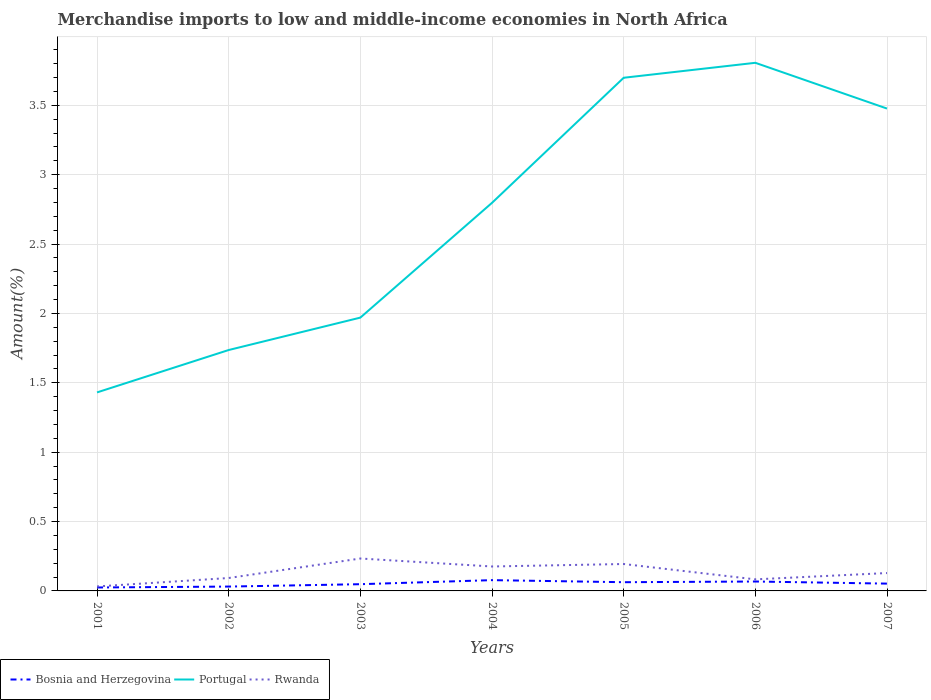How many different coloured lines are there?
Offer a terse response. 3. Is the number of lines equal to the number of legend labels?
Offer a terse response. Yes. Across all years, what is the maximum percentage of amount earned from merchandise imports in Rwanda?
Provide a succinct answer. 0.03. In which year was the percentage of amount earned from merchandise imports in Portugal maximum?
Keep it short and to the point. 2001. What is the total percentage of amount earned from merchandise imports in Portugal in the graph?
Your response must be concise. -1.51. What is the difference between the highest and the second highest percentage of amount earned from merchandise imports in Rwanda?
Make the answer very short. 0.2. What is the difference between the highest and the lowest percentage of amount earned from merchandise imports in Rwanda?
Your answer should be very brief. 3. What is the difference between two consecutive major ticks on the Y-axis?
Your response must be concise. 0.5. Does the graph contain any zero values?
Give a very brief answer. No. Does the graph contain grids?
Give a very brief answer. Yes. Where does the legend appear in the graph?
Provide a short and direct response. Bottom left. How are the legend labels stacked?
Provide a short and direct response. Horizontal. What is the title of the graph?
Make the answer very short. Merchandise imports to low and middle-income economies in North Africa. What is the label or title of the X-axis?
Your answer should be very brief. Years. What is the label or title of the Y-axis?
Provide a short and direct response. Amount(%). What is the Amount(%) in Bosnia and Herzegovina in 2001?
Your answer should be very brief. 0.02. What is the Amount(%) of Portugal in 2001?
Offer a terse response. 1.43. What is the Amount(%) of Rwanda in 2001?
Offer a terse response. 0.03. What is the Amount(%) of Bosnia and Herzegovina in 2002?
Ensure brevity in your answer.  0.03. What is the Amount(%) in Portugal in 2002?
Your response must be concise. 1.74. What is the Amount(%) in Rwanda in 2002?
Offer a very short reply. 0.09. What is the Amount(%) in Bosnia and Herzegovina in 2003?
Keep it short and to the point. 0.05. What is the Amount(%) of Portugal in 2003?
Your answer should be very brief. 1.97. What is the Amount(%) in Rwanda in 2003?
Provide a short and direct response. 0.23. What is the Amount(%) in Bosnia and Herzegovina in 2004?
Keep it short and to the point. 0.08. What is the Amount(%) in Portugal in 2004?
Keep it short and to the point. 2.8. What is the Amount(%) in Rwanda in 2004?
Make the answer very short. 0.18. What is the Amount(%) in Bosnia and Herzegovina in 2005?
Make the answer very short. 0.06. What is the Amount(%) of Portugal in 2005?
Provide a succinct answer. 3.7. What is the Amount(%) of Rwanda in 2005?
Keep it short and to the point. 0.19. What is the Amount(%) of Bosnia and Herzegovina in 2006?
Offer a very short reply. 0.07. What is the Amount(%) in Portugal in 2006?
Give a very brief answer. 3.81. What is the Amount(%) of Rwanda in 2006?
Offer a terse response. 0.08. What is the Amount(%) in Bosnia and Herzegovina in 2007?
Your answer should be very brief. 0.05. What is the Amount(%) in Portugal in 2007?
Provide a succinct answer. 3.48. What is the Amount(%) of Rwanda in 2007?
Ensure brevity in your answer.  0.13. Across all years, what is the maximum Amount(%) of Bosnia and Herzegovina?
Offer a terse response. 0.08. Across all years, what is the maximum Amount(%) in Portugal?
Keep it short and to the point. 3.81. Across all years, what is the maximum Amount(%) in Rwanda?
Provide a succinct answer. 0.23. Across all years, what is the minimum Amount(%) in Bosnia and Herzegovina?
Your response must be concise. 0.02. Across all years, what is the minimum Amount(%) of Portugal?
Make the answer very short. 1.43. Across all years, what is the minimum Amount(%) of Rwanda?
Provide a short and direct response. 0.03. What is the total Amount(%) of Bosnia and Herzegovina in the graph?
Your answer should be compact. 0.37. What is the total Amount(%) of Portugal in the graph?
Make the answer very short. 18.92. What is the total Amount(%) in Rwanda in the graph?
Your answer should be compact. 0.94. What is the difference between the Amount(%) of Bosnia and Herzegovina in 2001 and that in 2002?
Provide a succinct answer. -0.01. What is the difference between the Amount(%) of Portugal in 2001 and that in 2002?
Ensure brevity in your answer.  -0.31. What is the difference between the Amount(%) in Rwanda in 2001 and that in 2002?
Provide a short and direct response. -0.06. What is the difference between the Amount(%) in Bosnia and Herzegovina in 2001 and that in 2003?
Ensure brevity in your answer.  -0.02. What is the difference between the Amount(%) of Portugal in 2001 and that in 2003?
Make the answer very short. -0.54. What is the difference between the Amount(%) in Rwanda in 2001 and that in 2003?
Make the answer very short. -0.2. What is the difference between the Amount(%) of Bosnia and Herzegovina in 2001 and that in 2004?
Provide a short and direct response. -0.05. What is the difference between the Amount(%) of Portugal in 2001 and that in 2004?
Make the answer very short. -1.37. What is the difference between the Amount(%) in Rwanda in 2001 and that in 2004?
Ensure brevity in your answer.  -0.14. What is the difference between the Amount(%) of Bosnia and Herzegovina in 2001 and that in 2005?
Provide a succinct answer. -0.04. What is the difference between the Amount(%) of Portugal in 2001 and that in 2005?
Offer a terse response. -2.27. What is the difference between the Amount(%) in Rwanda in 2001 and that in 2005?
Make the answer very short. -0.16. What is the difference between the Amount(%) of Bosnia and Herzegovina in 2001 and that in 2006?
Make the answer very short. -0.04. What is the difference between the Amount(%) of Portugal in 2001 and that in 2006?
Provide a succinct answer. -2.38. What is the difference between the Amount(%) in Rwanda in 2001 and that in 2006?
Your answer should be very brief. -0.05. What is the difference between the Amount(%) in Bosnia and Herzegovina in 2001 and that in 2007?
Ensure brevity in your answer.  -0.03. What is the difference between the Amount(%) in Portugal in 2001 and that in 2007?
Your answer should be very brief. -2.05. What is the difference between the Amount(%) of Rwanda in 2001 and that in 2007?
Provide a short and direct response. -0.1. What is the difference between the Amount(%) of Bosnia and Herzegovina in 2002 and that in 2003?
Ensure brevity in your answer.  -0.02. What is the difference between the Amount(%) of Portugal in 2002 and that in 2003?
Provide a short and direct response. -0.23. What is the difference between the Amount(%) of Rwanda in 2002 and that in 2003?
Provide a short and direct response. -0.14. What is the difference between the Amount(%) in Bosnia and Herzegovina in 2002 and that in 2004?
Provide a short and direct response. -0.05. What is the difference between the Amount(%) of Portugal in 2002 and that in 2004?
Make the answer very short. -1.06. What is the difference between the Amount(%) in Rwanda in 2002 and that in 2004?
Your answer should be very brief. -0.08. What is the difference between the Amount(%) in Bosnia and Herzegovina in 2002 and that in 2005?
Offer a very short reply. -0.03. What is the difference between the Amount(%) in Portugal in 2002 and that in 2005?
Ensure brevity in your answer.  -1.96. What is the difference between the Amount(%) of Rwanda in 2002 and that in 2005?
Make the answer very short. -0.1. What is the difference between the Amount(%) in Bosnia and Herzegovina in 2002 and that in 2006?
Your answer should be compact. -0.04. What is the difference between the Amount(%) of Portugal in 2002 and that in 2006?
Keep it short and to the point. -2.07. What is the difference between the Amount(%) of Rwanda in 2002 and that in 2006?
Provide a succinct answer. 0.01. What is the difference between the Amount(%) of Bosnia and Herzegovina in 2002 and that in 2007?
Your answer should be very brief. -0.02. What is the difference between the Amount(%) in Portugal in 2002 and that in 2007?
Provide a short and direct response. -1.74. What is the difference between the Amount(%) in Rwanda in 2002 and that in 2007?
Ensure brevity in your answer.  -0.04. What is the difference between the Amount(%) in Bosnia and Herzegovina in 2003 and that in 2004?
Your answer should be compact. -0.03. What is the difference between the Amount(%) in Portugal in 2003 and that in 2004?
Provide a succinct answer. -0.83. What is the difference between the Amount(%) in Rwanda in 2003 and that in 2004?
Offer a very short reply. 0.06. What is the difference between the Amount(%) in Bosnia and Herzegovina in 2003 and that in 2005?
Your answer should be compact. -0.01. What is the difference between the Amount(%) in Portugal in 2003 and that in 2005?
Provide a succinct answer. -1.73. What is the difference between the Amount(%) of Rwanda in 2003 and that in 2005?
Offer a terse response. 0.04. What is the difference between the Amount(%) in Bosnia and Herzegovina in 2003 and that in 2006?
Your answer should be very brief. -0.02. What is the difference between the Amount(%) of Portugal in 2003 and that in 2006?
Your answer should be very brief. -1.84. What is the difference between the Amount(%) of Rwanda in 2003 and that in 2006?
Provide a succinct answer. 0.15. What is the difference between the Amount(%) of Bosnia and Herzegovina in 2003 and that in 2007?
Give a very brief answer. -0. What is the difference between the Amount(%) in Portugal in 2003 and that in 2007?
Your answer should be compact. -1.51. What is the difference between the Amount(%) of Rwanda in 2003 and that in 2007?
Give a very brief answer. 0.1. What is the difference between the Amount(%) of Bosnia and Herzegovina in 2004 and that in 2005?
Give a very brief answer. 0.01. What is the difference between the Amount(%) of Portugal in 2004 and that in 2005?
Offer a terse response. -0.9. What is the difference between the Amount(%) in Rwanda in 2004 and that in 2005?
Make the answer very short. -0.02. What is the difference between the Amount(%) of Bosnia and Herzegovina in 2004 and that in 2006?
Provide a succinct answer. 0.01. What is the difference between the Amount(%) in Portugal in 2004 and that in 2006?
Ensure brevity in your answer.  -1.01. What is the difference between the Amount(%) in Rwanda in 2004 and that in 2006?
Keep it short and to the point. 0.09. What is the difference between the Amount(%) of Bosnia and Herzegovina in 2004 and that in 2007?
Your answer should be very brief. 0.03. What is the difference between the Amount(%) of Portugal in 2004 and that in 2007?
Provide a short and direct response. -0.68. What is the difference between the Amount(%) in Rwanda in 2004 and that in 2007?
Offer a very short reply. 0.05. What is the difference between the Amount(%) in Bosnia and Herzegovina in 2005 and that in 2006?
Offer a very short reply. -0.01. What is the difference between the Amount(%) in Portugal in 2005 and that in 2006?
Provide a short and direct response. -0.11. What is the difference between the Amount(%) in Rwanda in 2005 and that in 2006?
Give a very brief answer. 0.11. What is the difference between the Amount(%) in Bosnia and Herzegovina in 2005 and that in 2007?
Make the answer very short. 0.01. What is the difference between the Amount(%) of Portugal in 2005 and that in 2007?
Keep it short and to the point. 0.22. What is the difference between the Amount(%) in Rwanda in 2005 and that in 2007?
Your response must be concise. 0.07. What is the difference between the Amount(%) of Bosnia and Herzegovina in 2006 and that in 2007?
Provide a succinct answer. 0.02. What is the difference between the Amount(%) in Portugal in 2006 and that in 2007?
Make the answer very short. 0.33. What is the difference between the Amount(%) of Rwanda in 2006 and that in 2007?
Offer a very short reply. -0.05. What is the difference between the Amount(%) of Bosnia and Herzegovina in 2001 and the Amount(%) of Portugal in 2002?
Keep it short and to the point. -1.71. What is the difference between the Amount(%) of Bosnia and Herzegovina in 2001 and the Amount(%) of Rwanda in 2002?
Offer a very short reply. -0.07. What is the difference between the Amount(%) of Portugal in 2001 and the Amount(%) of Rwanda in 2002?
Your response must be concise. 1.34. What is the difference between the Amount(%) in Bosnia and Herzegovina in 2001 and the Amount(%) in Portugal in 2003?
Your answer should be compact. -1.95. What is the difference between the Amount(%) of Bosnia and Herzegovina in 2001 and the Amount(%) of Rwanda in 2003?
Offer a very short reply. -0.21. What is the difference between the Amount(%) of Portugal in 2001 and the Amount(%) of Rwanda in 2003?
Keep it short and to the point. 1.2. What is the difference between the Amount(%) of Bosnia and Herzegovina in 2001 and the Amount(%) of Portugal in 2004?
Keep it short and to the point. -2.77. What is the difference between the Amount(%) of Bosnia and Herzegovina in 2001 and the Amount(%) of Rwanda in 2004?
Offer a terse response. -0.15. What is the difference between the Amount(%) of Portugal in 2001 and the Amount(%) of Rwanda in 2004?
Offer a very short reply. 1.25. What is the difference between the Amount(%) in Bosnia and Herzegovina in 2001 and the Amount(%) in Portugal in 2005?
Give a very brief answer. -3.67. What is the difference between the Amount(%) of Bosnia and Herzegovina in 2001 and the Amount(%) of Rwanda in 2005?
Ensure brevity in your answer.  -0.17. What is the difference between the Amount(%) in Portugal in 2001 and the Amount(%) in Rwanda in 2005?
Offer a very short reply. 1.24. What is the difference between the Amount(%) in Bosnia and Herzegovina in 2001 and the Amount(%) in Portugal in 2006?
Make the answer very short. -3.78. What is the difference between the Amount(%) in Bosnia and Herzegovina in 2001 and the Amount(%) in Rwanda in 2006?
Give a very brief answer. -0.06. What is the difference between the Amount(%) of Portugal in 2001 and the Amount(%) of Rwanda in 2006?
Provide a short and direct response. 1.35. What is the difference between the Amount(%) of Bosnia and Herzegovina in 2001 and the Amount(%) of Portugal in 2007?
Provide a short and direct response. -3.45. What is the difference between the Amount(%) of Bosnia and Herzegovina in 2001 and the Amount(%) of Rwanda in 2007?
Ensure brevity in your answer.  -0.1. What is the difference between the Amount(%) of Portugal in 2001 and the Amount(%) of Rwanda in 2007?
Your answer should be very brief. 1.3. What is the difference between the Amount(%) in Bosnia and Herzegovina in 2002 and the Amount(%) in Portugal in 2003?
Your answer should be compact. -1.94. What is the difference between the Amount(%) in Bosnia and Herzegovina in 2002 and the Amount(%) in Rwanda in 2003?
Keep it short and to the point. -0.2. What is the difference between the Amount(%) of Portugal in 2002 and the Amount(%) of Rwanda in 2003?
Ensure brevity in your answer.  1.5. What is the difference between the Amount(%) in Bosnia and Herzegovina in 2002 and the Amount(%) in Portugal in 2004?
Your answer should be very brief. -2.77. What is the difference between the Amount(%) of Bosnia and Herzegovina in 2002 and the Amount(%) of Rwanda in 2004?
Make the answer very short. -0.14. What is the difference between the Amount(%) in Portugal in 2002 and the Amount(%) in Rwanda in 2004?
Provide a succinct answer. 1.56. What is the difference between the Amount(%) of Bosnia and Herzegovina in 2002 and the Amount(%) of Portugal in 2005?
Your answer should be compact. -3.67. What is the difference between the Amount(%) in Bosnia and Herzegovina in 2002 and the Amount(%) in Rwanda in 2005?
Offer a very short reply. -0.16. What is the difference between the Amount(%) in Portugal in 2002 and the Amount(%) in Rwanda in 2005?
Provide a succinct answer. 1.54. What is the difference between the Amount(%) in Bosnia and Herzegovina in 2002 and the Amount(%) in Portugal in 2006?
Give a very brief answer. -3.77. What is the difference between the Amount(%) in Bosnia and Herzegovina in 2002 and the Amount(%) in Rwanda in 2006?
Make the answer very short. -0.05. What is the difference between the Amount(%) in Portugal in 2002 and the Amount(%) in Rwanda in 2006?
Ensure brevity in your answer.  1.65. What is the difference between the Amount(%) in Bosnia and Herzegovina in 2002 and the Amount(%) in Portugal in 2007?
Your response must be concise. -3.45. What is the difference between the Amount(%) in Bosnia and Herzegovina in 2002 and the Amount(%) in Rwanda in 2007?
Provide a short and direct response. -0.1. What is the difference between the Amount(%) of Portugal in 2002 and the Amount(%) of Rwanda in 2007?
Your response must be concise. 1.61. What is the difference between the Amount(%) of Bosnia and Herzegovina in 2003 and the Amount(%) of Portugal in 2004?
Provide a short and direct response. -2.75. What is the difference between the Amount(%) in Bosnia and Herzegovina in 2003 and the Amount(%) in Rwanda in 2004?
Your response must be concise. -0.13. What is the difference between the Amount(%) in Portugal in 2003 and the Amount(%) in Rwanda in 2004?
Provide a short and direct response. 1.79. What is the difference between the Amount(%) of Bosnia and Herzegovina in 2003 and the Amount(%) of Portugal in 2005?
Provide a succinct answer. -3.65. What is the difference between the Amount(%) in Bosnia and Herzegovina in 2003 and the Amount(%) in Rwanda in 2005?
Your answer should be compact. -0.15. What is the difference between the Amount(%) of Portugal in 2003 and the Amount(%) of Rwanda in 2005?
Provide a short and direct response. 1.78. What is the difference between the Amount(%) of Bosnia and Herzegovina in 2003 and the Amount(%) of Portugal in 2006?
Give a very brief answer. -3.76. What is the difference between the Amount(%) in Bosnia and Herzegovina in 2003 and the Amount(%) in Rwanda in 2006?
Offer a terse response. -0.03. What is the difference between the Amount(%) in Portugal in 2003 and the Amount(%) in Rwanda in 2006?
Make the answer very short. 1.89. What is the difference between the Amount(%) in Bosnia and Herzegovina in 2003 and the Amount(%) in Portugal in 2007?
Keep it short and to the point. -3.43. What is the difference between the Amount(%) of Bosnia and Herzegovina in 2003 and the Amount(%) of Rwanda in 2007?
Provide a succinct answer. -0.08. What is the difference between the Amount(%) of Portugal in 2003 and the Amount(%) of Rwanda in 2007?
Your answer should be very brief. 1.84. What is the difference between the Amount(%) of Bosnia and Herzegovina in 2004 and the Amount(%) of Portugal in 2005?
Keep it short and to the point. -3.62. What is the difference between the Amount(%) in Bosnia and Herzegovina in 2004 and the Amount(%) in Rwanda in 2005?
Offer a very short reply. -0.12. What is the difference between the Amount(%) in Portugal in 2004 and the Amount(%) in Rwanda in 2005?
Your answer should be very brief. 2.6. What is the difference between the Amount(%) of Bosnia and Herzegovina in 2004 and the Amount(%) of Portugal in 2006?
Your response must be concise. -3.73. What is the difference between the Amount(%) of Bosnia and Herzegovina in 2004 and the Amount(%) of Rwanda in 2006?
Offer a very short reply. -0.01. What is the difference between the Amount(%) in Portugal in 2004 and the Amount(%) in Rwanda in 2006?
Your answer should be compact. 2.71. What is the difference between the Amount(%) of Bosnia and Herzegovina in 2004 and the Amount(%) of Portugal in 2007?
Ensure brevity in your answer.  -3.4. What is the difference between the Amount(%) of Bosnia and Herzegovina in 2004 and the Amount(%) of Rwanda in 2007?
Provide a succinct answer. -0.05. What is the difference between the Amount(%) of Portugal in 2004 and the Amount(%) of Rwanda in 2007?
Provide a short and direct response. 2.67. What is the difference between the Amount(%) of Bosnia and Herzegovina in 2005 and the Amount(%) of Portugal in 2006?
Your answer should be very brief. -3.74. What is the difference between the Amount(%) of Bosnia and Herzegovina in 2005 and the Amount(%) of Rwanda in 2006?
Your response must be concise. -0.02. What is the difference between the Amount(%) of Portugal in 2005 and the Amount(%) of Rwanda in 2006?
Your response must be concise. 3.62. What is the difference between the Amount(%) of Bosnia and Herzegovina in 2005 and the Amount(%) of Portugal in 2007?
Offer a terse response. -3.41. What is the difference between the Amount(%) of Bosnia and Herzegovina in 2005 and the Amount(%) of Rwanda in 2007?
Make the answer very short. -0.07. What is the difference between the Amount(%) of Portugal in 2005 and the Amount(%) of Rwanda in 2007?
Ensure brevity in your answer.  3.57. What is the difference between the Amount(%) of Bosnia and Herzegovina in 2006 and the Amount(%) of Portugal in 2007?
Ensure brevity in your answer.  -3.41. What is the difference between the Amount(%) of Bosnia and Herzegovina in 2006 and the Amount(%) of Rwanda in 2007?
Your answer should be compact. -0.06. What is the difference between the Amount(%) of Portugal in 2006 and the Amount(%) of Rwanda in 2007?
Offer a terse response. 3.68. What is the average Amount(%) of Bosnia and Herzegovina per year?
Ensure brevity in your answer.  0.05. What is the average Amount(%) in Portugal per year?
Make the answer very short. 2.7. What is the average Amount(%) of Rwanda per year?
Your answer should be compact. 0.13. In the year 2001, what is the difference between the Amount(%) of Bosnia and Herzegovina and Amount(%) of Portugal?
Your answer should be very brief. -1.41. In the year 2001, what is the difference between the Amount(%) of Bosnia and Herzegovina and Amount(%) of Rwanda?
Give a very brief answer. -0.01. In the year 2001, what is the difference between the Amount(%) of Portugal and Amount(%) of Rwanda?
Offer a very short reply. 1.4. In the year 2002, what is the difference between the Amount(%) in Bosnia and Herzegovina and Amount(%) in Portugal?
Ensure brevity in your answer.  -1.7. In the year 2002, what is the difference between the Amount(%) in Bosnia and Herzegovina and Amount(%) in Rwanda?
Offer a very short reply. -0.06. In the year 2002, what is the difference between the Amount(%) in Portugal and Amount(%) in Rwanda?
Keep it short and to the point. 1.64. In the year 2003, what is the difference between the Amount(%) of Bosnia and Herzegovina and Amount(%) of Portugal?
Provide a succinct answer. -1.92. In the year 2003, what is the difference between the Amount(%) of Bosnia and Herzegovina and Amount(%) of Rwanda?
Provide a short and direct response. -0.19. In the year 2003, what is the difference between the Amount(%) in Portugal and Amount(%) in Rwanda?
Offer a very short reply. 1.74. In the year 2004, what is the difference between the Amount(%) in Bosnia and Herzegovina and Amount(%) in Portugal?
Make the answer very short. -2.72. In the year 2004, what is the difference between the Amount(%) of Bosnia and Herzegovina and Amount(%) of Rwanda?
Provide a short and direct response. -0.1. In the year 2004, what is the difference between the Amount(%) in Portugal and Amount(%) in Rwanda?
Give a very brief answer. 2.62. In the year 2005, what is the difference between the Amount(%) in Bosnia and Herzegovina and Amount(%) in Portugal?
Your answer should be very brief. -3.64. In the year 2005, what is the difference between the Amount(%) in Bosnia and Herzegovina and Amount(%) in Rwanda?
Offer a terse response. -0.13. In the year 2005, what is the difference between the Amount(%) of Portugal and Amount(%) of Rwanda?
Your answer should be very brief. 3.5. In the year 2006, what is the difference between the Amount(%) in Bosnia and Herzegovina and Amount(%) in Portugal?
Your answer should be very brief. -3.74. In the year 2006, what is the difference between the Amount(%) of Bosnia and Herzegovina and Amount(%) of Rwanda?
Provide a succinct answer. -0.02. In the year 2006, what is the difference between the Amount(%) of Portugal and Amount(%) of Rwanda?
Offer a very short reply. 3.72. In the year 2007, what is the difference between the Amount(%) of Bosnia and Herzegovina and Amount(%) of Portugal?
Give a very brief answer. -3.42. In the year 2007, what is the difference between the Amount(%) of Bosnia and Herzegovina and Amount(%) of Rwanda?
Give a very brief answer. -0.08. In the year 2007, what is the difference between the Amount(%) in Portugal and Amount(%) in Rwanda?
Your response must be concise. 3.35. What is the ratio of the Amount(%) of Bosnia and Herzegovina in 2001 to that in 2002?
Give a very brief answer. 0.79. What is the ratio of the Amount(%) in Portugal in 2001 to that in 2002?
Ensure brevity in your answer.  0.82. What is the ratio of the Amount(%) of Rwanda in 2001 to that in 2002?
Make the answer very short. 0.35. What is the ratio of the Amount(%) of Bosnia and Herzegovina in 2001 to that in 2003?
Your answer should be compact. 0.51. What is the ratio of the Amount(%) of Portugal in 2001 to that in 2003?
Give a very brief answer. 0.73. What is the ratio of the Amount(%) in Rwanda in 2001 to that in 2003?
Make the answer very short. 0.14. What is the ratio of the Amount(%) of Bosnia and Herzegovina in 2001 to that in 2004?
Offer a very short reply. 0.32. What is the ratio of the Amount(%) in Portugal in 2001 to that in 2004?
Offer a terse response. 0.51. What is the ratio of the Amount(%) in Rwanda in 2001 to that in 2004?
Offer a terse response. 0.18. What is the ratio of the Amount(%) of Bosnia and Herzegovina in 2001 to that in 2005?
Keep it short and to the point. 0.39. What is the ratio of the Amount(%) in Portugal in 2001 to that in 2005?
Offer a very short reply. 0.39. What is the ratio of the Amount(%) of Rwanda in 2001 to that in 2005?
Keep it short and to the point. 0.17. What is the ratio of the Amount(%) in Bosnia and Herzegovina in 2001 to that in 2006?
Offer a terse response. 0.36. What is the ratio of the Amount(%) in Portugal in 2001 to that in 2006?
Provide a succinct answer. 0.38. What is the ratio of the Amount(%) of Rwanda in 2001 to that in 2006?
Your answer should be very brief. 0.39. What is the ratio of the Amount(%) of Bosnia and Herzegovina in 2001 to that in 2007?
Offer a very short reply. 0.47. What is the ratio of the Amount(%) in Portugal in 2001 to that in 2007?
Offer a very short reply. 0.41. What is the ratio of the Amount(%) in Rwanda in 2001 to that in 2007?
Provide a succinct answer. 0.25. What is the ratio of the Amount(%) of Bosnia and Herzegovina in 2002 to that in 2003?
Ensure brevity in your answer.  0.65. What is the ratio of the Amount(%) in Portugal in 2002 to that in 2003?
Your answer should be very brief. 0.88. What is the ratio of the Amount(%) in Rwanda in 2002 to that in 2003?
Keep it short and to the point. 0.4. What is the ratio of the Amount(%) of Bosnia and Herzegovina in 2002 to that in 2004?
Your answer should be very brief. 0.4. What is the ratio of the Amount(%) of Portugal in 2002 to that in 2004?
Your answer should be compact. 0.62. What is the ratio of the Amount(%) of Rwanda in 2002 to that in 2004?
Offer a terse response. 0.53. What is the ratio of the Amount(%) in Bosnia and Herzegovina in 2002 to that in 2005?
Provide a short and direct response. 0.5. What is the ratio of the Amount(%) of Portugal in 2002 to that in 2005?
Give a very brief answer. 0.47. What is the ratio of the Amount(%) in Rwanda in 2002 to that in 2005?
Offer a terse response. 0.48. What is the ratio of the Amount(%) in Bosnia and Herzegovina in 2002 to that in 2006?
Your response must be concise. 0.46. What is the ratio of the Amount(%) of Portugal in 2002 to that in 2006?
Provide a succinct answer. 0.46. What is the ratio of the Amount(%) in Rwanda in 2002 to that in 2006?
Provide a succinct answer. 1.12. What is the ratio of the Amount(%) of Bosnia and Herzegovina in 2002 to that in 2007?
Give a very brief answer. 0.6. What is the ratio of the Amount(%) of Portugal in 2002 to that in 2007?
Provide a short and direct response. 0.5. What is the ratio of the Amount(%) in Rwanda in 2002 to that in 2007?
Provide a succinct answer. 0.72. What is the ratio of the Amount(%) in Bosnia and Herzegovina in 2003 to that in 2004?
Your answer should be very brief. 0.62. What is the ratio of the Amount(%) of Portugal in 2003 to that in 2004?
Offer a terse response. 0.7. What is the ratio of the Amount(%) in Rwanda in 2003 to that in 2004?
Your response must be concise. 1.33. What is the ratio of the Amount(%) of Bosnia and Herzegovina in 2003 to that in 2005?
Offer a terse response. 0.77. What is the ratio of the Amount(%) of Portugal in 2003 to that in 2005?
Your answer should be very brief. 0.53. What is the ratio of the Amount(%) in Rwanda in 2003 to that in 2005?
Give a very brief answer. 1.2. What is the ratio of the Amount(%) in Bosnia and Herzegovina in 2003 to that in 2006?
Ensure brevity in your answer.  0.71. What is the ratio of the Amount(%) in Portugal in 2003 to that in 2006?
Provide a short and direct response. 0.52. What is the ratio of the Amount(%) of Rwanda in 2003 to that in 2006?
Keep it short and to the point. 2.8. What is the ratio of the Amount(%) in Bosnia and Herzegovina in 2003 to that in 2007?
Give a very brief answer. 0.92. What is the ratio of the Amount(%) of Portugal in 2003 to that in 2007?
Offer a very short reply. 0.57. What is the ratio of the Amount(%) of Rwanda in 2003 to that in 2007?
Provide a succinct answer. 1.81. What is the ratio of the Amount(%) in Bosnia and Herzegovina in 2004 to that in 2005?
Give a very brief answer. 1.24. What is the ratio of the Amount(%) in Portugal in 2004 to that in 2005?
Give a very brief answer. 0.76. What is the ratio of the Amount(%) of Rwanda in 2004 to that in 2005?
Ensure brevity in your answer.  0.91. What is the ratio of the Amount(%) of Bosnia and Herzegovina in 2004 to that in 2006?
Offer a very short reply. 1.15. What is the ratio of the Amount(%) of Portugal in 2004 to that in 2006?
Provide a short and direct response. 0.73. What is the ratio of the Amount(%) in Rwanda in 2004 to that in 2006?
Ensure brevity in your answer.  2.11. What is the ratio of the Amount(%) of Bosnia and Herzegovina in 2004 to that in 2007?
Your response must be concise. 1.48. What is the ratio of the Amount(%) in Portugal in 2004 to that in 2007?
Offer a terse response. 0.8. What is the ratio of the Amount(%) in Rwanda in 2004 to that in 2007?
Give a very brief answer. 1.37. What is the ratio of the Amount(%) in Bosnia and Herzegovina in 2005 to that in 2006?
Your answer should be very brief. 0.93. What is the ratio of the Amount(%) in Portugal in 2005 to that in 2006?
Offer a very short reply. 0.97. What is the ratio of the Amount(%) of Rwanda in 2005 to that in 2006?
Your response must be concise. 2.33. What is the ratio of the Amount(%) in Bosnia and Herzegovina in 2005 to that in 2007?
Your answer should be compact. 1.19. What is the ratio of the Amount(%) in Portugal in 2005 to that in 2007?
Your response must be concise. 1.06. What is the ratio of the Amount(%) in Rwanda in 2005 to that in 2007?
Your answer should be very brief. 1.51. What is the ratio of the Amount(%) in Bosnia and Herzegovina in 2006 to that in 2007?
Ensure brevity in your answer.  1.29. What is the ratio of the Amount(%) in Portugal in 2006 to that in 2007?
Your response must be concise. 1.09. What is the ratio of the Amount(%) of Rwanda in 2006 to that in 2007?
Your answer should be very brief. 0.65. What is the difference between the highest and the second highest Amount(%) of Bosnia and Herzegovina?
Provide a short and direct response. 0.01. What is the difference between the highest and the second highest Amount(%) in Portugal?
Your answer should be very brief. 0.11. What is the difference between the highest and the second highest Amount(%) in Rwanda?
Offer a terse response. 0.04. What is the difference between the highest and the lowest Amount(%) in Bosnia and Herzegovina?
Offer a very short reply. 0.05. What is the difference between the highest and the lowest Amount(%) of Portugal?
Provide a short and direct response. 2.38. What is the difference between the highest and the lowest Amount(%) in Rwanda?
Offer a very short reply. 0.2. 